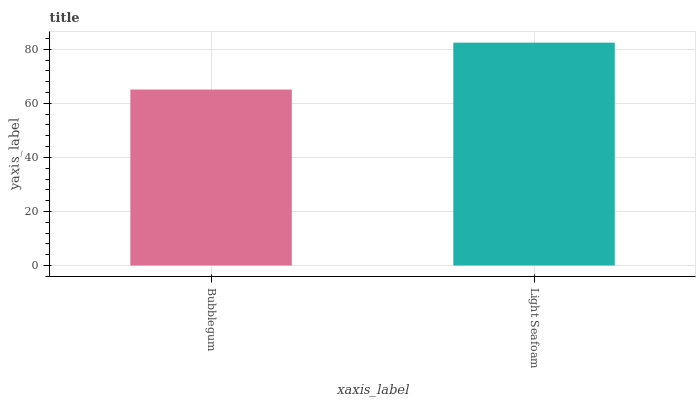Is Bubblegum the minimum?
Answer yes or no. Yes. Is Light Seafoam the maximum?
Answer yes or no. Yes. Is Light Seafoam the minimum?
Answer yes or no. No. Is Light Seafoam greater than Bubblegum?
Answer yes or no. Yes. Is Bubblegum less than Light Seafoam?
Answer yes or no. Yes. Is Bubblegum greater than Light Seafoam?
Answer yes or no. No. Is Light Seafoam less than Bubblegum?
Answer yes or no. No. Is Light Seafoam the high median?
Answer yes or no. Yes. Is Bubblegum the low median?
Answer yes or no. Yes. Is Bubblegum the high median?
Answer yes or no. No. Is Light Seafoam the low median?
Answer yes or no. No. 